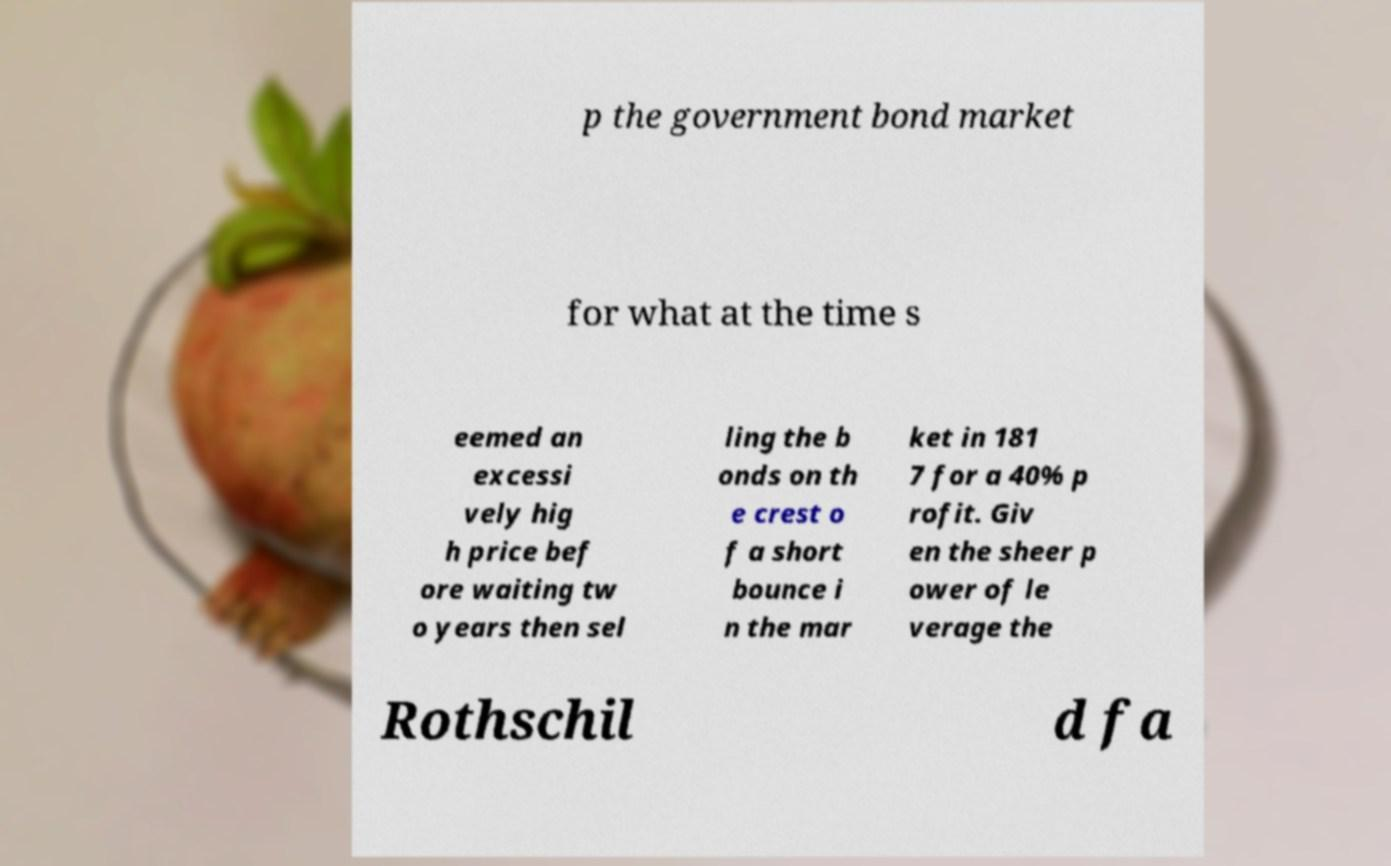Can you read and provide the text displayed in the image?This photo seems to have some interesting text. Can you extract and type it out for me? p the government bond market for what at the time s eemed an excessi vely hig h price bef ore waiting tw o years then sel ling the b onds on th e crest o f a short bounce i n the mar ket in 181 7 for a 40% p rofit. Giv en the sheer p ower of le verage the Rothschil d fa 